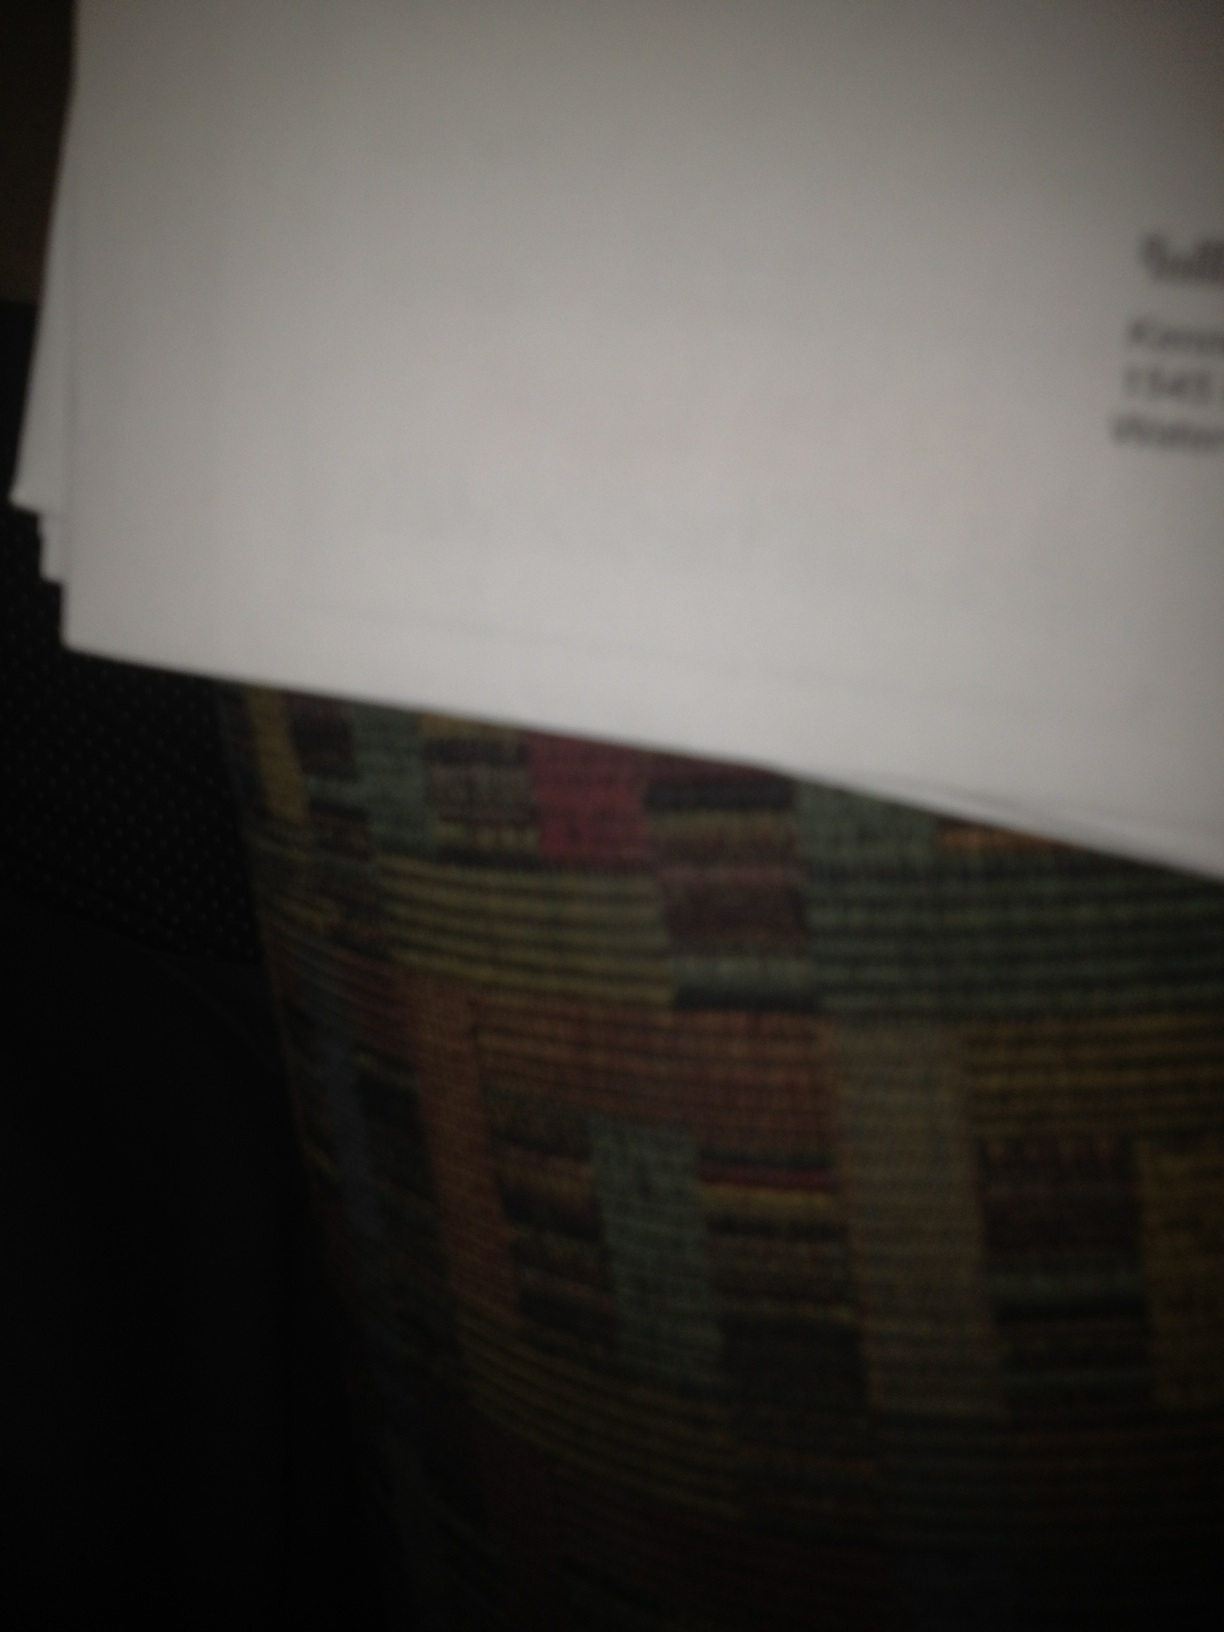Can you tell what type of document this might be, even if parts are blurred? From what's visible, it appears to be a standard letter or printed document. The slight glimpse of text format and the top part of the paper typically suggest a formal letter or similar correspondence. Is there any visible clue on the document that might hint at its origin? Given the blurriness of the image, precise details are obscured. If you need to know its origin, it might be helpful to look for any legible logos, watermarks, or even the type of paper, as these elements can sometimes indicate where it's from or whom it's associated with. 